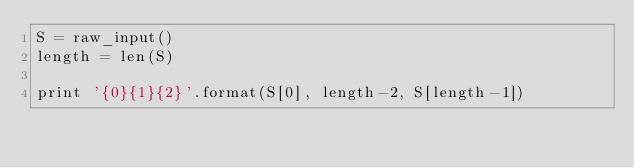Convert code to text. <code><loc_0><loc_0><loc_500><loc_500><_Python_>S = raw_input()
length = len(S)

print '{0}{1}{2}'.format(S[0], length-2, S[length-1])
</code> 